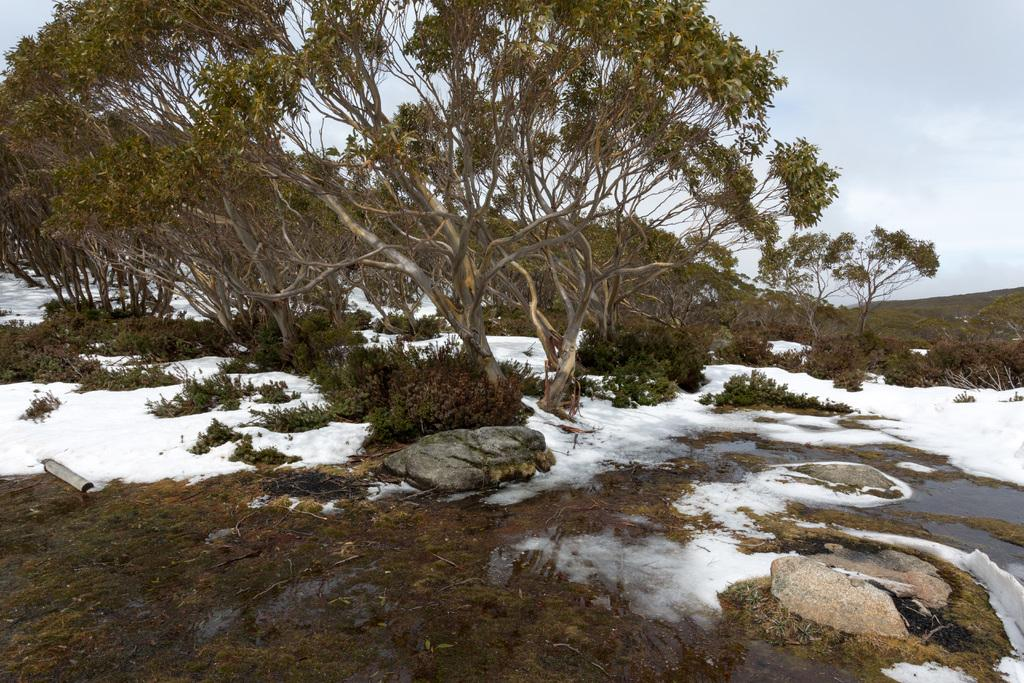What can be seen in the foreground of the picture? In the foreground of the picture, there are stones, snow, and water. What is located in the center of the picture? In the center of the picture, there are trees and plants, as well as snow. What is visible in the background of the picture? The sky is visible in the background of the picture. How would you describe the weather in the image? The presence of snow and the cloudy sky suggest that the weather is cold and possibly overcast. What type of rice is being cooked in the image? There is no rice present in the image; it features stones, snow, water, trees, plants, and a cloudy sky. Can you tell me how many goats are visible in the image? There are no goats present in the image. 